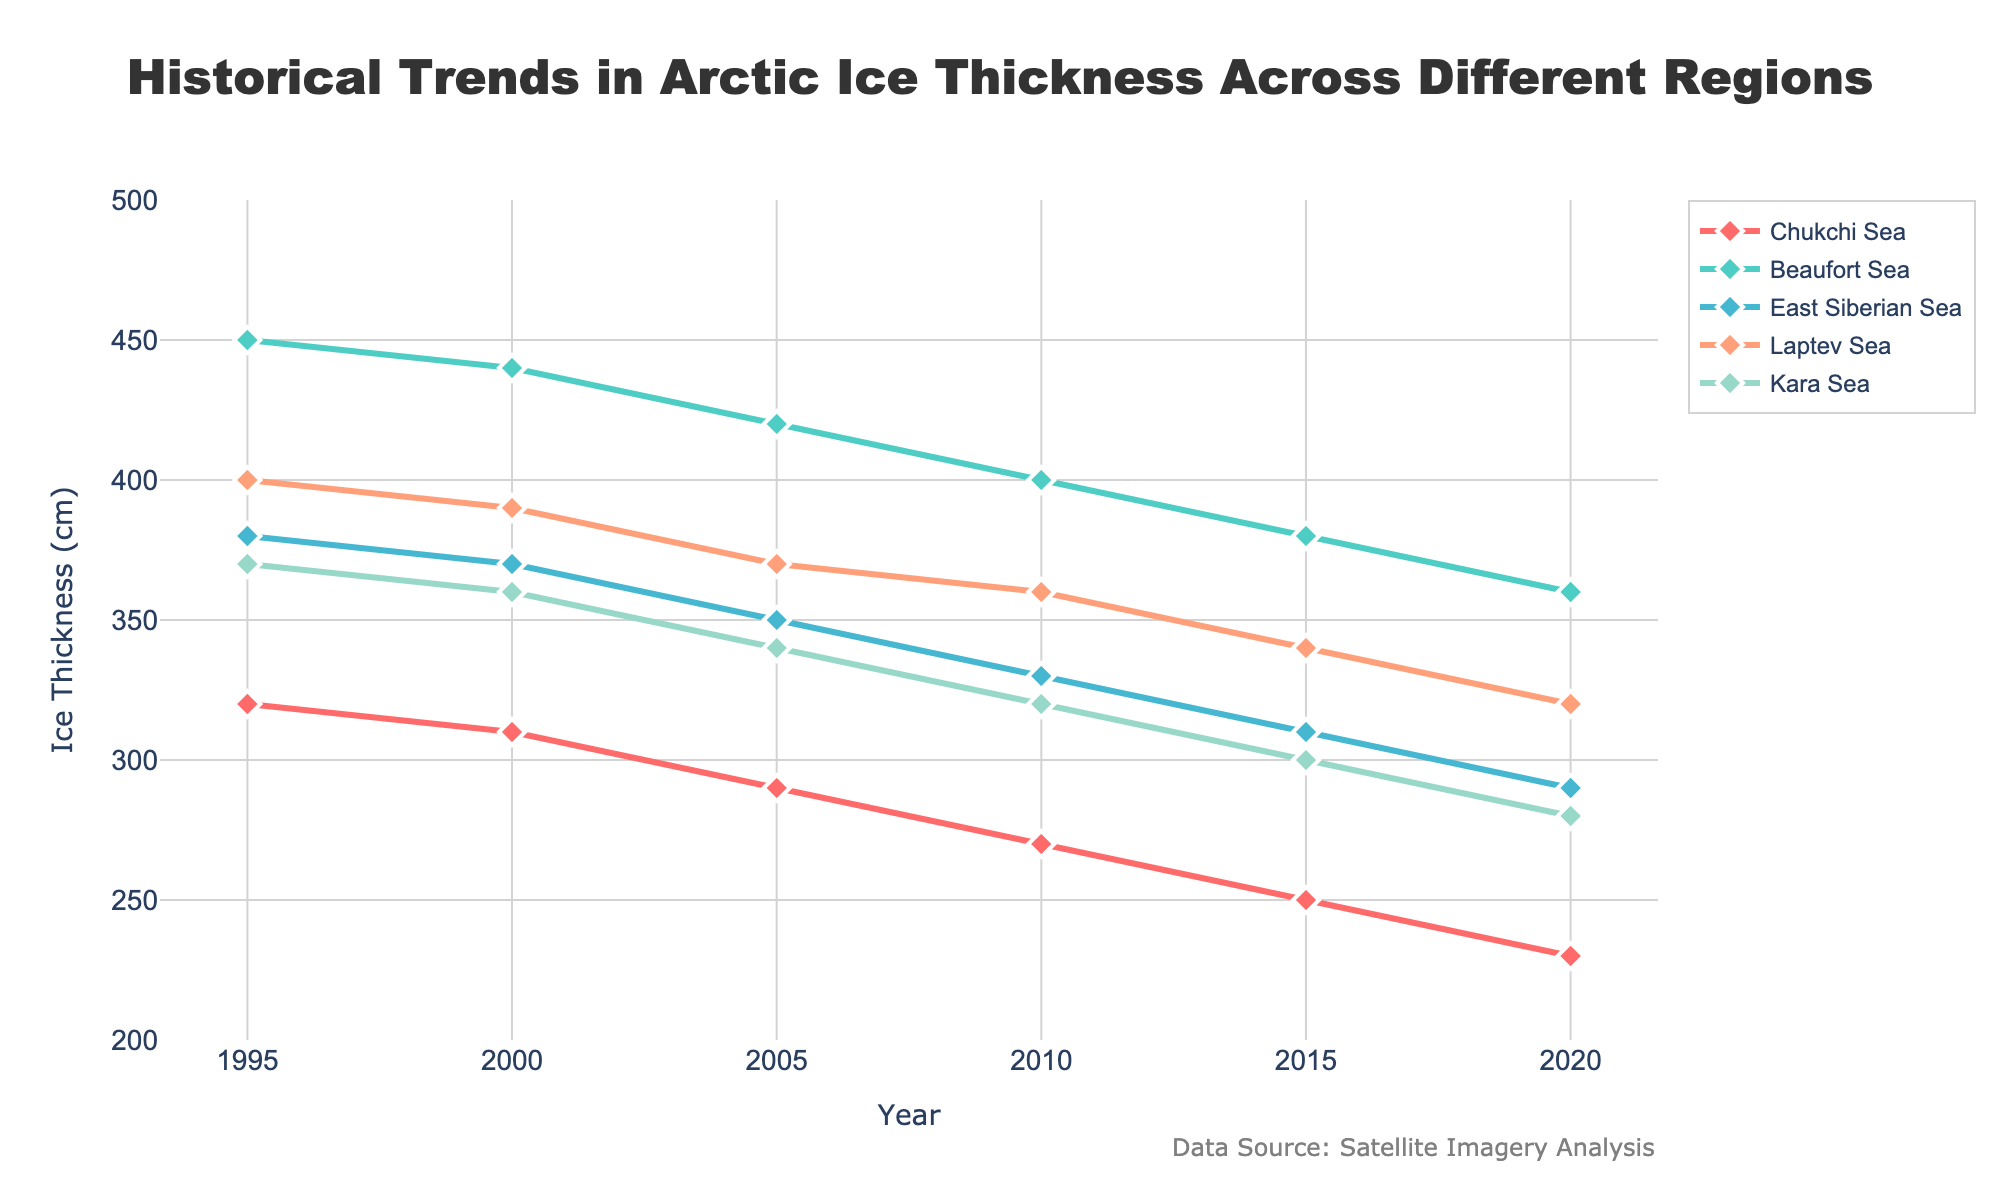What is the overall trend in ice thickness over the years for the Chukchi Sea? By observing the line representing the Chukchi Sea, it consistently decreases from 320 cm in 1995 to 230 cm in 2020. The trend is a steady decline over the years.
Answer: Decreasing What was the ice thickness in the Beaufort Sea in 2005? To find the ice thickness in the Beaufort Sea for 2005, locate the Beaufort Sea line and check the value at the 2005 mark on the x-axis. The y-axis value is 420 cm.
Answer: 420 cm Which region had the highest ice thickness in 1995 and what was its value? Checking the starting point of all lines in 1995, the Beaufort Sea had the highest ice thickness, which was 450 cm.
Answer: Beaufort Sea, 450 cm How much did the ice thickness in the Kara Sea change from 2000 to 2020? Calculate the difference between the ice thicknesses in 2020 and 2000 for the Kara Sea. In 2020, it was 280 cm, and in 2000, it was 360 cm. The change is 360 - 280.
Answer: 80 cm Which region shows the steepest decrease in ice thickness over time? By observing all lines, the Chukchi Sea shows the steepest decrease, dropping from 320 cm in 1995 to 230 cm in 2020. No other region shows such a rapid and continuous decline.
Answer: Chukchi Sea Between which years did the ice thickness in the East Siberian Sea decrease the most? Looking at the East Siberian Sea line, the steepest drop is between 2005 and 2010, from 350 cm to 330 cm.
Answer: 2005 and 2010 What is the range of ice thickness values across all regions in the year 2010? Looking at the y-values for all regions in 2010, the highest is 400 cm (Beaufort Sea) and the lowest is 270 cm (Chukchi Sea). The range is 400 - 270 = 130 cm.
Answer: 130 cm How has the Laptev Sea ice thickness changed on average every 5 years from 1995 to 2020? To find the average change, calculate the yearly differences for Laptev Sea and then average them every 5 years. Initial: 400 cm (1995), 390 cm (2000), 370 cm (2005), 360 cm (2010), 340 cm (2015), 320 cm (2020). Average every 5-year changes: (400-390)+ (390-370)+ (370-360)+ (360-340)+ (340-320) divided by 5.
Answer: -16 cm per 5 years 